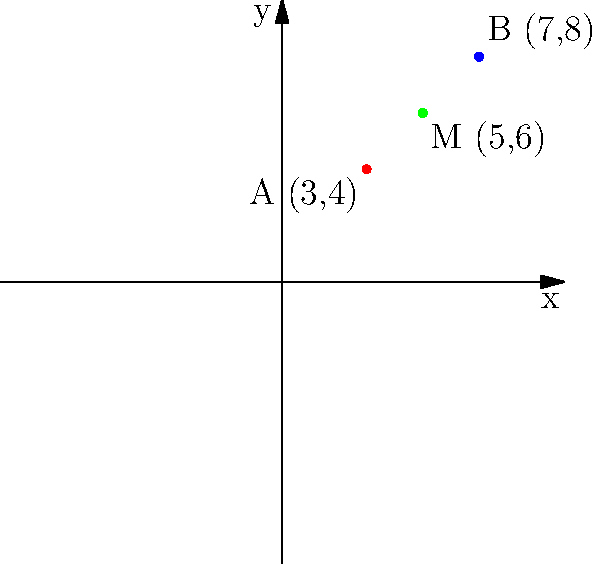Two popular heavy metal bands are scheduled to perform concerts in different cities. Band A will perform at coordinates (3,4), while Band B will perform at coordinates (7,8). To maximize promotional efforts, you want to organize a meet-and-greet event at the midpoint between these two concert locations. What are the coordinates of this midpoint where you should host the promotional event? To find the midpoint between two points, we use the midpoint formula:

$$ M_x = \frac{x_1 + x_2}{2}, M_y = \frac{y_1 + y_2}{2} $$

Where $(x_1, y_1)$ are the coordinates of the first point and $(x_2, y_2)$ are the coordinates of the second point.

Step 1: Identify the coordinates
- Point A (Band A's concert): $(x_1, y_1) = (3, 4)$
- Point B (Band B's concert): $(x_2, y_2) = (7, 8)$

Step 2: Calculate the x-coordinate of the midpoint
$$ M_x = \frac{x_1 + x_2}{2} = \frac{3 + 7}{2} = \frac{10}{2} = 5 $$

Step 3: Calculate the y-coordinate of the midpoint
$$ M_y = \frac{y_1 + y_2}{2} = \frac{4 + 8}{2} = \frac{12}{2} = 6 $$

Step 4: Combine the results
The midpoint M is $(M_x, M_y) = (5, 6)$
Answer: (5, 6) 